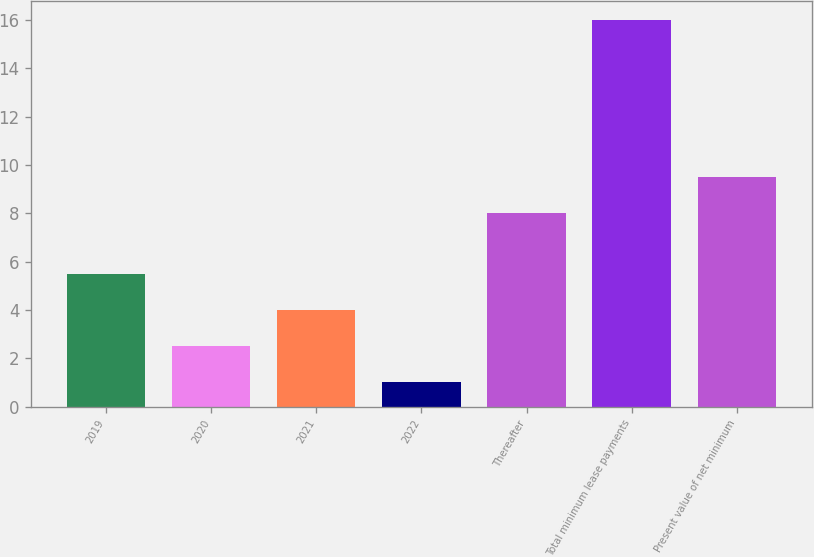Convert chart. <chart><loc_0><loc_0><loc_500><loc_500><bar_chart><fcel>2019<fcel>2020<fcel>2021<fcel>2022<fcel>Thereafter<fcel>Total minimum lease payments<fcel>Present value of net minimum<nl><fcel>5.5<fcel>2.5<fcel>4<fcel>1<fcel>8<fcel>16<fcel>9.5<nl></chart> 